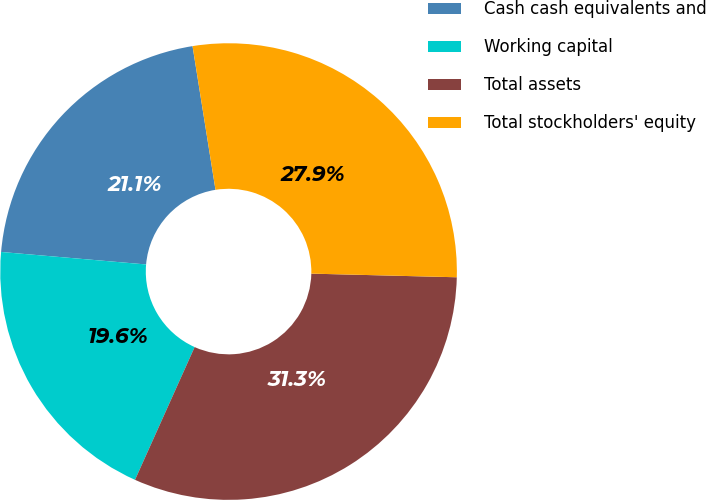Convert chart. <chart><loc_0><loc_0><loc_500><loc_500><pie_chart><fcel>Cash cash equivalents and<fcel>Working capital<fcel>Total assets<fcel>Total stockholders' equity<nl><fcel>21.11%<fcel>19.65%<fcel>31.32%<fcel>27.92%<nl></chart> 